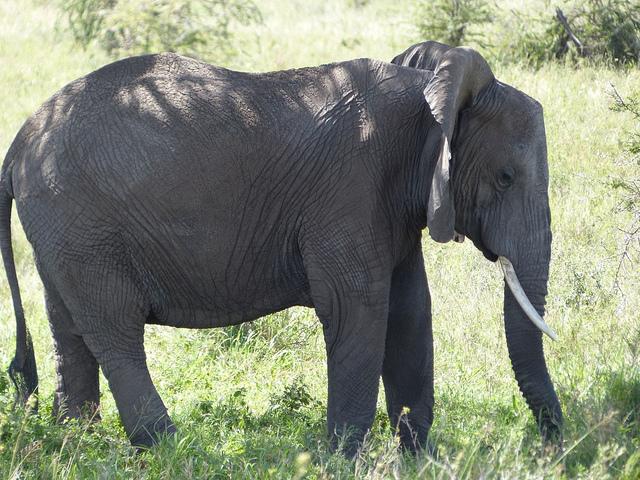How long are the tusks?
Keep it brief. 2 feet. Are there any stones on the ground?
Quick response, please. No. What would this elephant be poached for?
Give a very brief answer. Tusks. Is there a baby present?
Be succinct. No. Does the elephant have tusks?
Keep it brief. Yes. Is the elephant in the wild?
Concise answer only. Yes. What color is the water the elephant is standing in?
Keep it brief. None. 